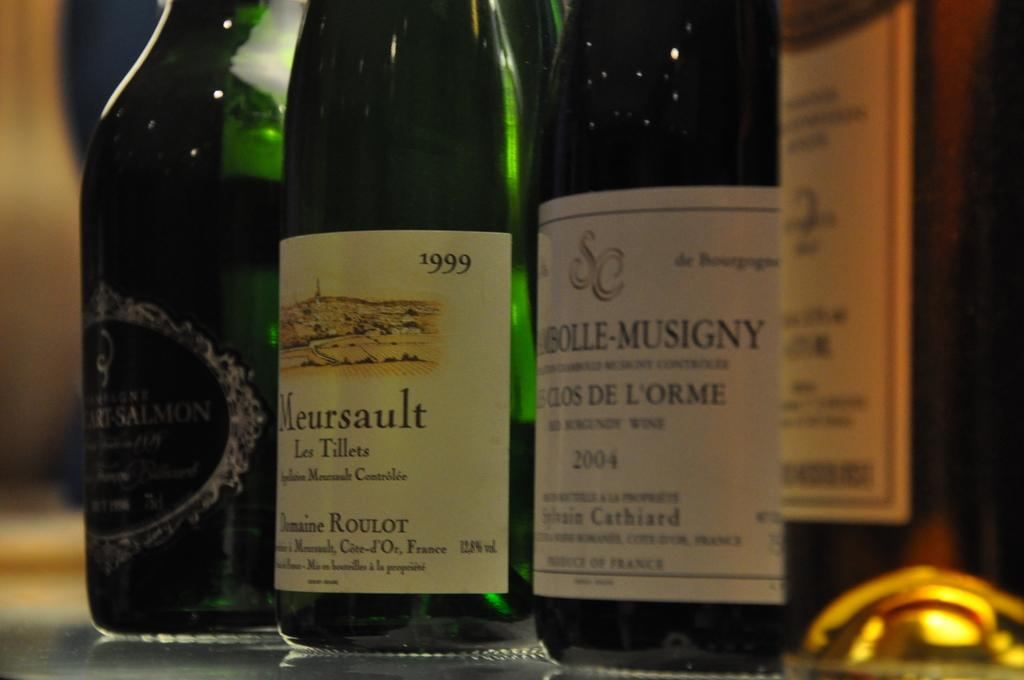<image>
Describe the image concisely. Several bottles of wine on a table one called Meursault 